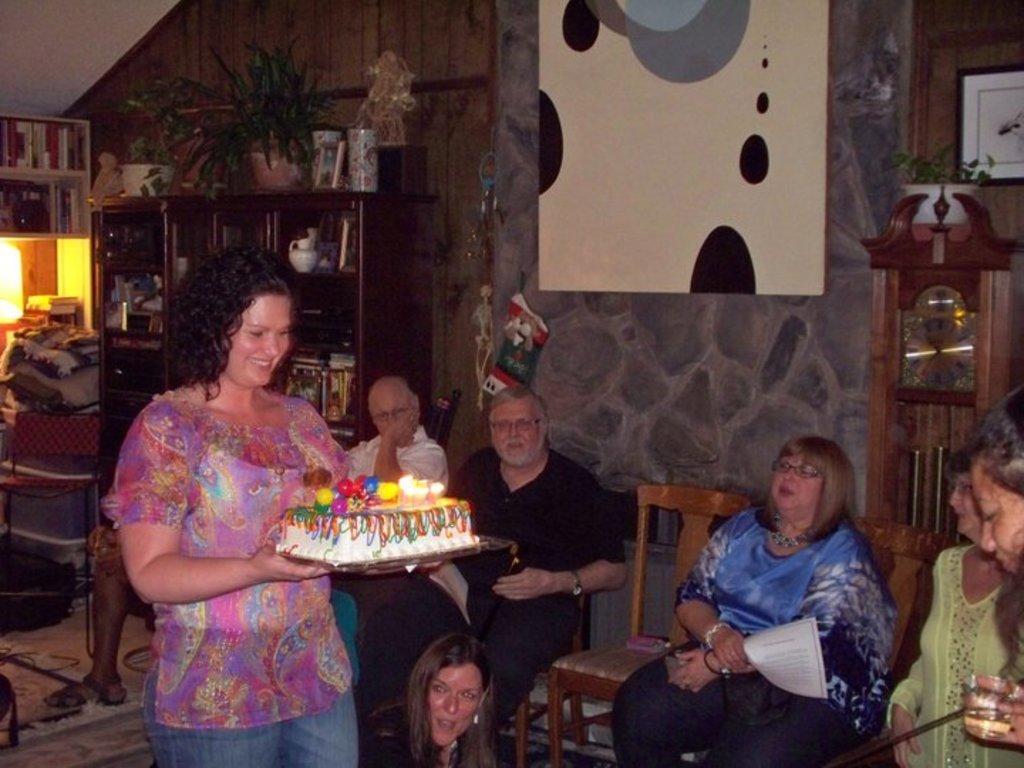Could you give a brief overview of what you see in this image? This woman is standing and holding a cake. These persons are sitting on a chair. This rack is filled with things and plant. Far this rack is filled with books. A poster on wall. 